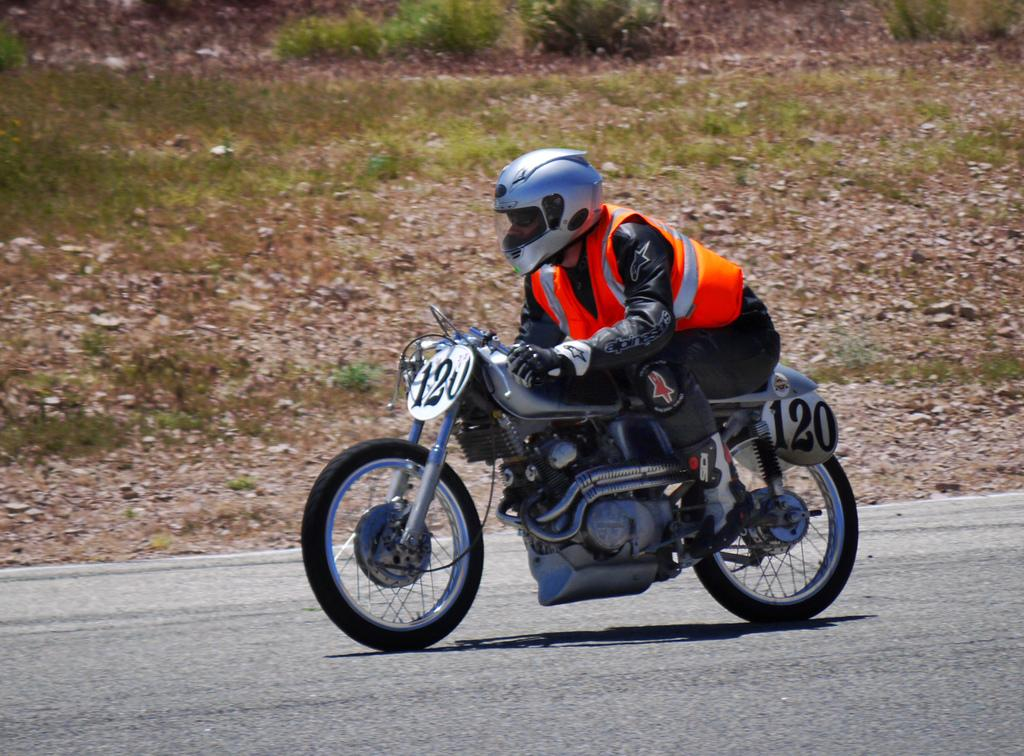What is the person in the image doing? The person is sitting and riding a bike. What safety gear is the person wearing? The person is wearing a helmet. What can be seen on the bike? There are number boards on the bike. What type of environment is visible in the background of the image? There is grass and plants in the background of the image. What type of whistle can be heard in the image? There is no whistle present in the image, and therefore no sound can be heard. What territory is being claimed by the person riding the bike in the image? There is no indication of territory in the image; it simply shows a person riding a bike with number boards. 